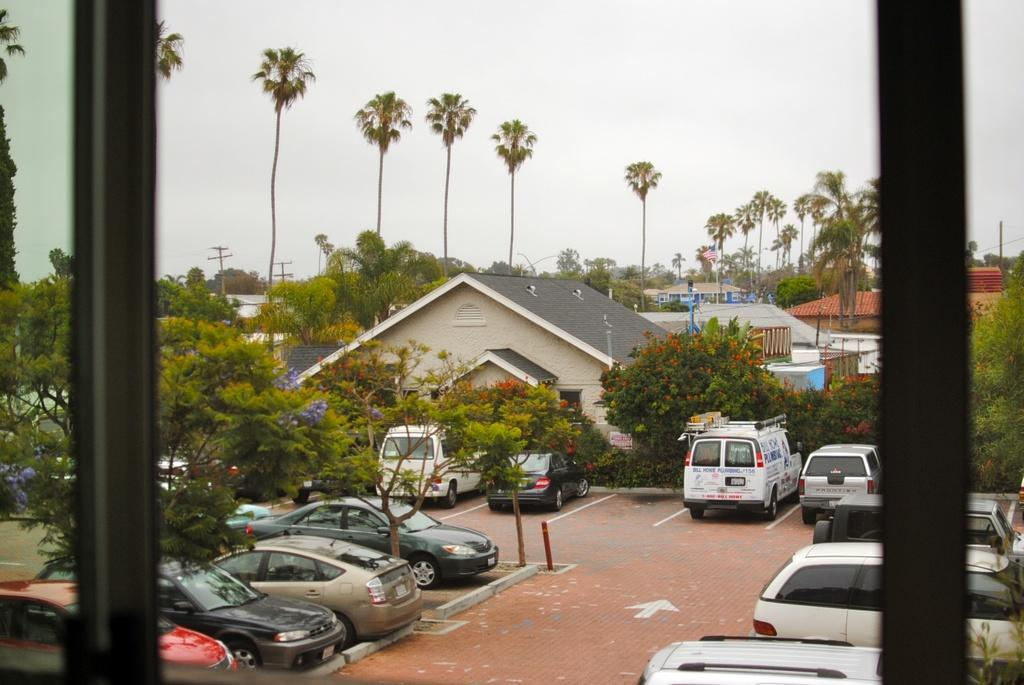What is located in the foreground of the image? There is a window glass in the foreground of the image. What can be seen in the background of the image? There are many trees, buildings, and cars on the road in the background of the image. What is visible at the top of the image? The sky is visible at the top of the image. What type of lamp is hanging from the window in the image? There is no lamp hanging from the window in the image; it is a window glass without any additional objects. 